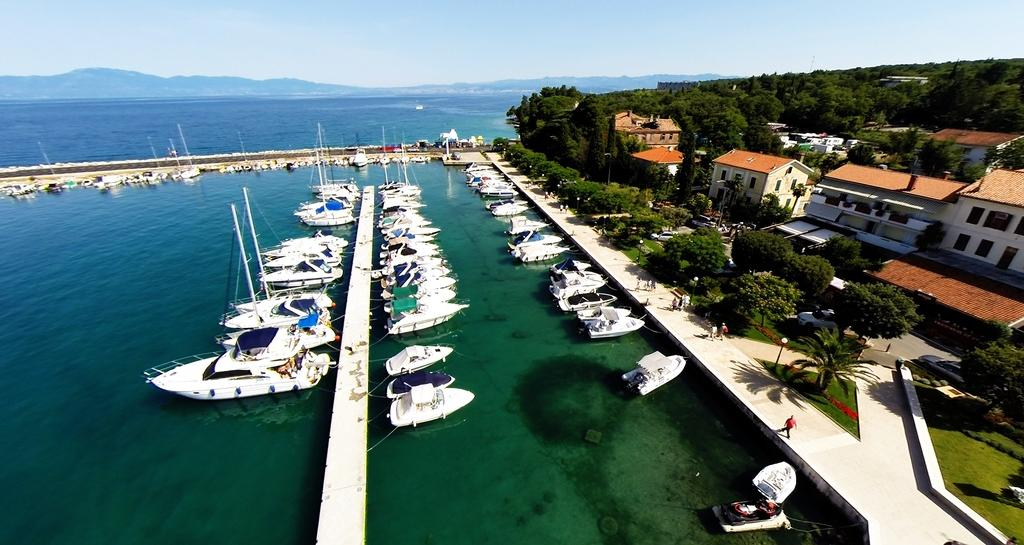What is the main feature of the image? The main feature of the image is water. What can be seen floating on the water? There are boats in the image. What type of vegetation is present in the image? There are trees and grass in the image. What type of structures can be seen in the image? There are houses in the image. What is visible at the top of the image? The sky is visible at the top of the image. How many eyes can be seen on the boats in the image? There are no eyes visible on the boats in the image, as boats do not have eyes. What type of calculator is present in the image? There is no calculator present in the image. 